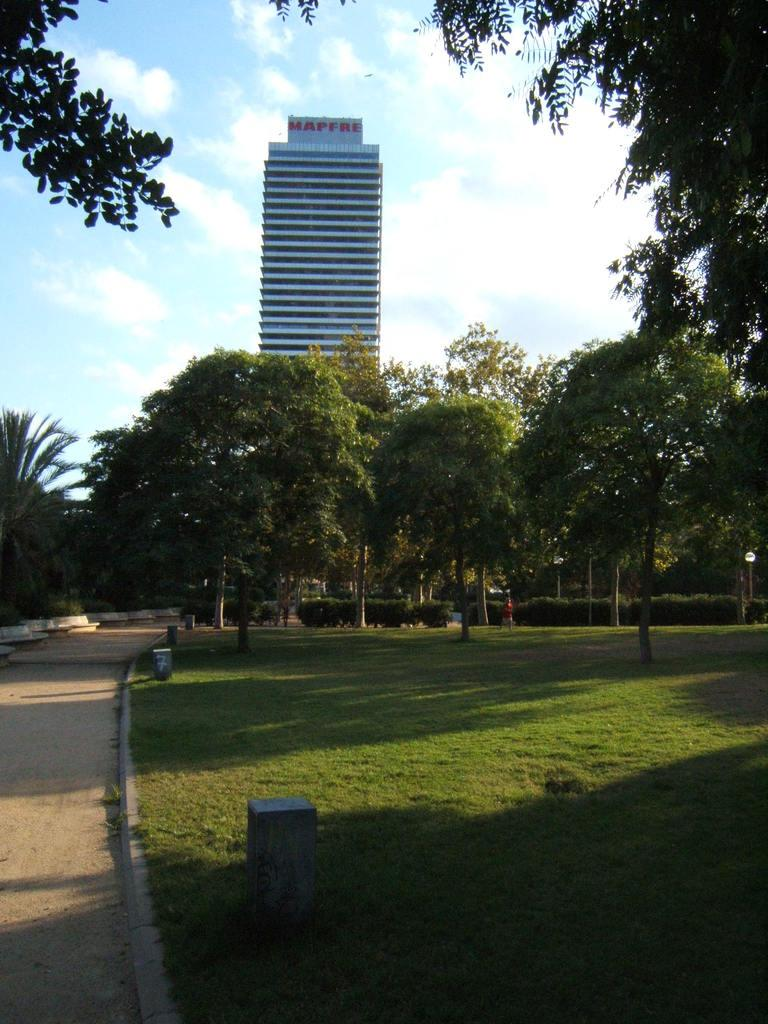What type of structure is visible in the image? There is a building in the image. Is there any signage or identification for the building? Yes, there is a name board in the image. What other natural elements can be seen in the image? There are trees in the image. Are there any waste management facilities in the image? Yes, there are bins in the image. What can be seen on the ground in the image? The ground is visible in the image. What is visible in the sky in the image? The sky is visible in the image, and there are clouds present in the sky. What type of skin can be seen on the trees in the image? There is no mention of skin in the image. Trees are natural elements with leaves and bark, not skin. 